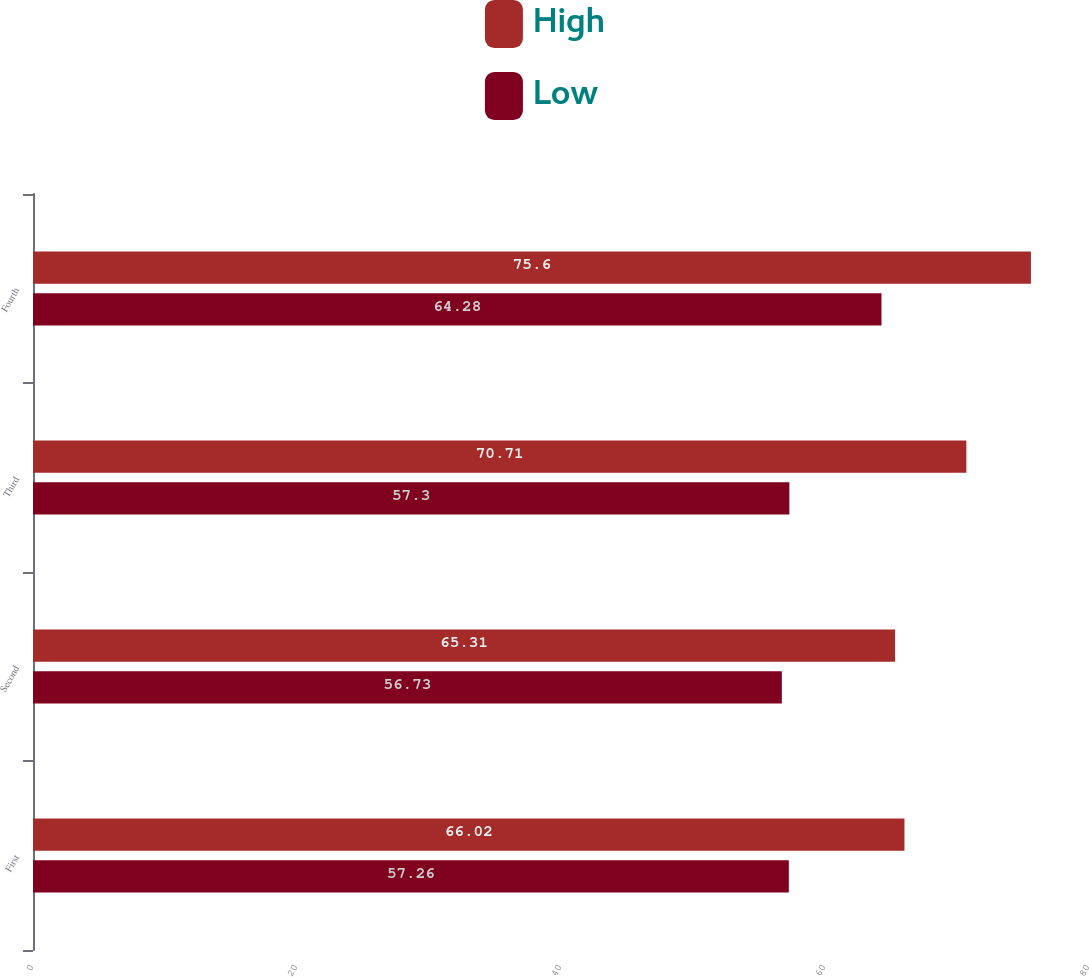<chart> <loc_0><loc_0><loc_500><loc_500><stacked_bar_chart><ecel><fcel>First<fcel>Second<fcel>Third<fcel>Fourth<nl><fcel>High<fcel>66.02<fcel>65.31<fcel>70.71<fcel>75.6<nl><fcel>Low<fcel>57.26<fcel>56.73<fcel>57.3<fcel>64.28<nl></chart> 